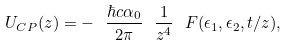Convert formula to latex. <formula><loc_0><loc_0><loc_500><loc_500>U _ { C P } ( z ) = - \ \frac { \hbar { c } \alpha _ { 0 } } { 2 \pi } \ \frac { 1 } { z ^ { 4 } } \ F ( \epsilon _ { 1 } , \epsilon _ { 2 } , t / z ) ,</formula> 